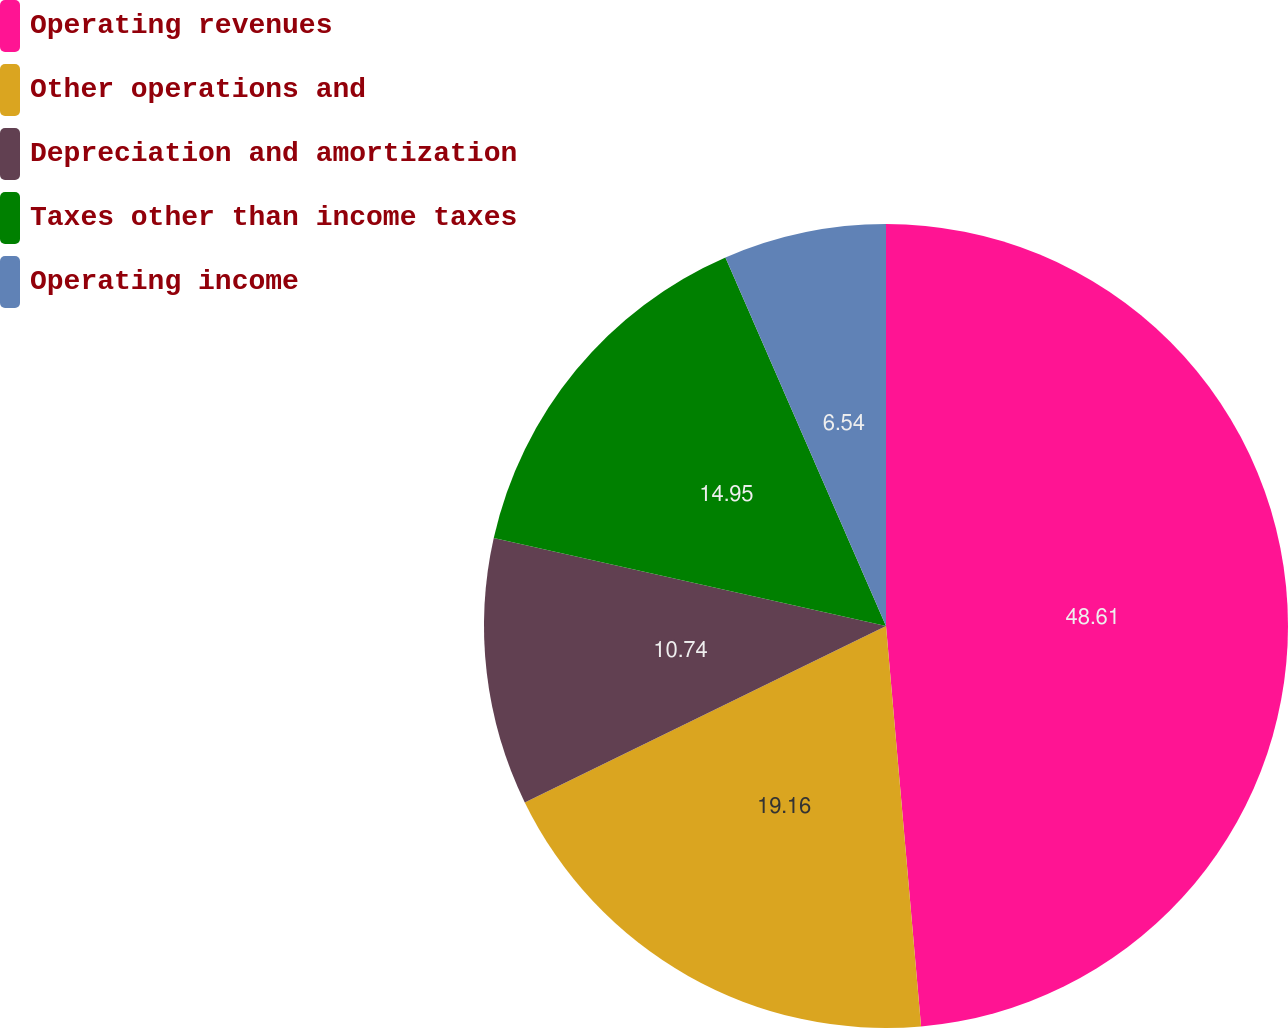Convert chart to OTSL. <chart><loc_0><loc_0><loc_500><loc_500><pie_chart><fcel>Operating revenues<fcel>Other operations and<fcel>Depreciation and amortization<fcel>Taxes other than income taxes<fcel>Operating income<nl><fcel>48.61%<fcel>19.16%<fcel>10.74%<fcel>14.95%<fcel>6.54%<nl></chart> 